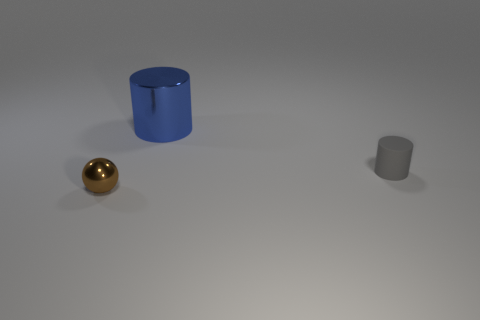There is a tiny thing that is the same shape as the big metallic thing; what material is it?
Make the answer very short. Rubber. Do the cylinder that is left of the gray cylinder and the gray cylinder have the same material?
Provide a short and direct response. No. Is the material of the cylinder to the right of the large blue thing the same as the object that is behind the matte cylinder?
Offer a very short reply. No. How many things are small brown shiny balls or tiny gray rubber cylinders?
Provide a succinct answer. 2. What number of small things are on the left side of the cylinder that is to the left of the small gray cylinder?
Provide a succinct answer. 1. Are there more large gray metallic cylinders than small cylinders?
Give a very brief answer. No. Is the material of the tiny gray cylinder the same as the sphere?
Offer a terse response. No. Is the number of matte cylinders that are behind the brown shiny sphere the same as the number of large brown metallic things?
Keep it short and to the point. No. What number of gray things have the same material as the blue thing?
Your answer should be very brief. 0. Is the number of tiny gray cylinders less than the number of tiny things?
Your response must be concise. Yes. 